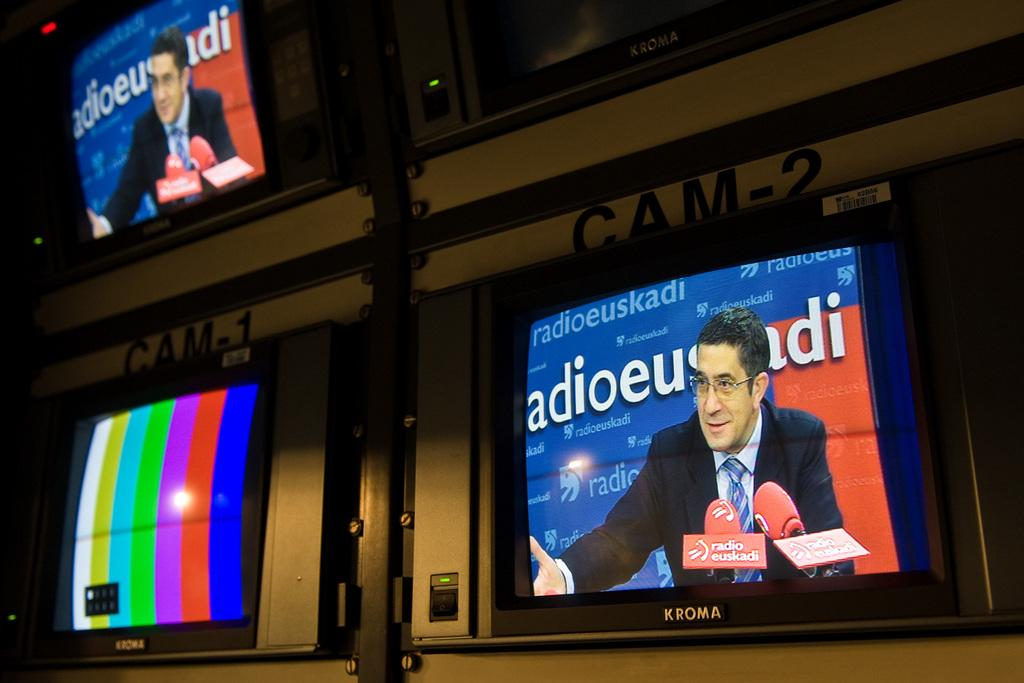<image>
Describe the image concisely. A man talks into microphones in front of a wall that says radioeuskadi. 